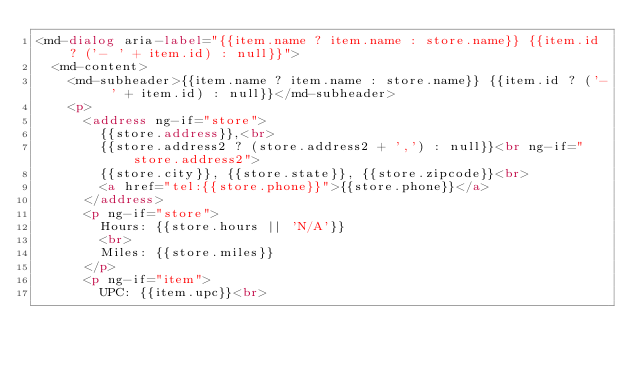<code> <loc_0><loc_0><loc_500><loc_500><_HTML_><md-dialog aria-label="{{item.name ? item.name : store.name}} {{item.id ? ('- ' + item.id) : null}}">
  <md-content>
    <md-subheader>{{item.name ? item.name : store.name}} {{item.id ? ('- ' + item.id) : null}}</md-subheader>
    <p>
      <address ng-if="store">
        {{store.address}},<br>
        {{store.address2 ? (store.address2 + ',') : null}}<br ng-if="store.address2">
        {{store.city}}, {{store.state}}, {{store.zipcode}}<br>
        <a href="tel:{{store.phone}}">{{store.phone}}</a>
      </address>
      <p ng-if="store">
        Hours: {{store.hours || 'N/A'}}
        <br>
        Miles: {{store.miles}}
      </p>
      <p ng-if="item">
        UPC: {{item.upc}}<br></code> 